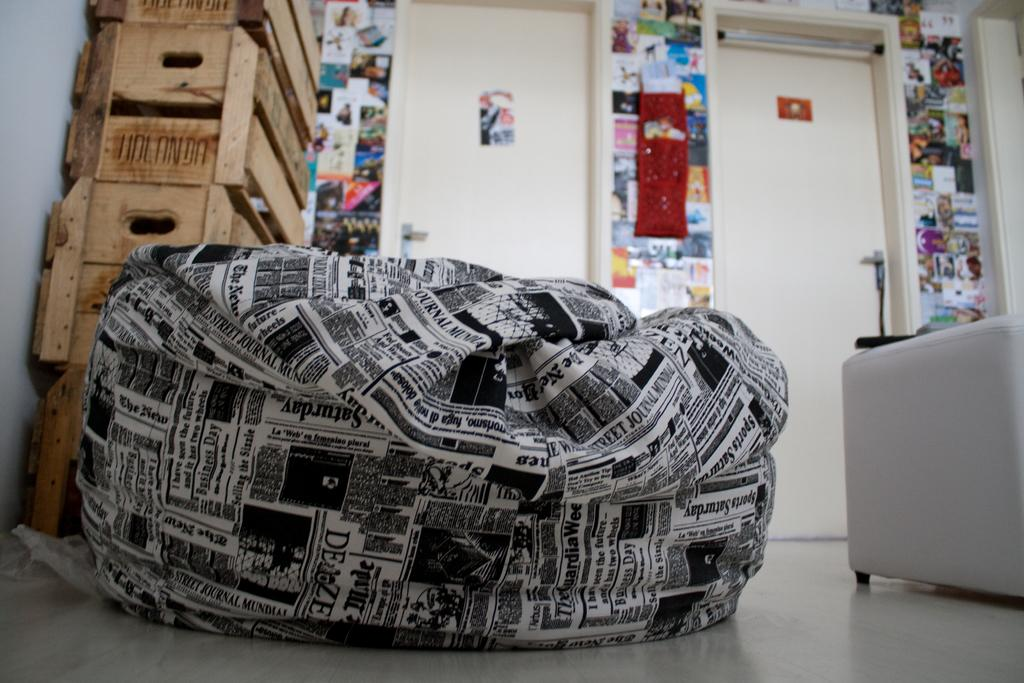What type of furniture is on the floor in the image? There is a bean bag on the floor in the image. What else can be seen on the floor besides the bean bag? There are wooden boxes on the floor. What is visible in the background of the image? There is a door and posters on the wall in the background. What type of letter is the carpenter writing on the bean bag in the image? There is no carpenter or letter present in the image. How does the balance of the wooden boxes on the floor affect the stability of the bean bag? The balance of the wooden boxes on the floor does not affect the stability of the bean bag in the image, as they are separate objects. 